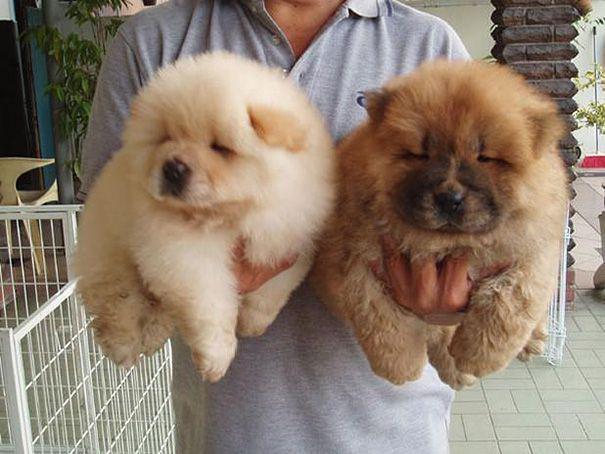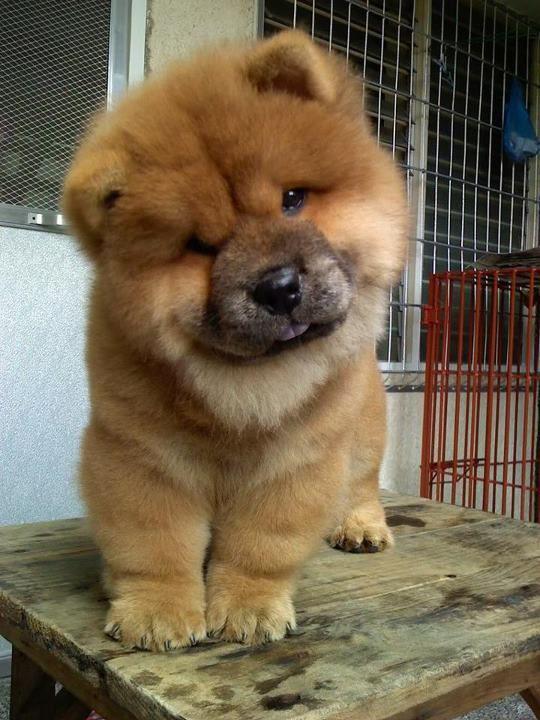The first image is the image on the left, the second image is the image on the right. Considering the images on both sides, is "One of the images shows at least two dogs." valid? Answer yes or no. Yes. The first image is the image on the left, the second image is the image on the right. Considering the images on both sides, is "There are two dogs" valid? Answer yes or no. No. 